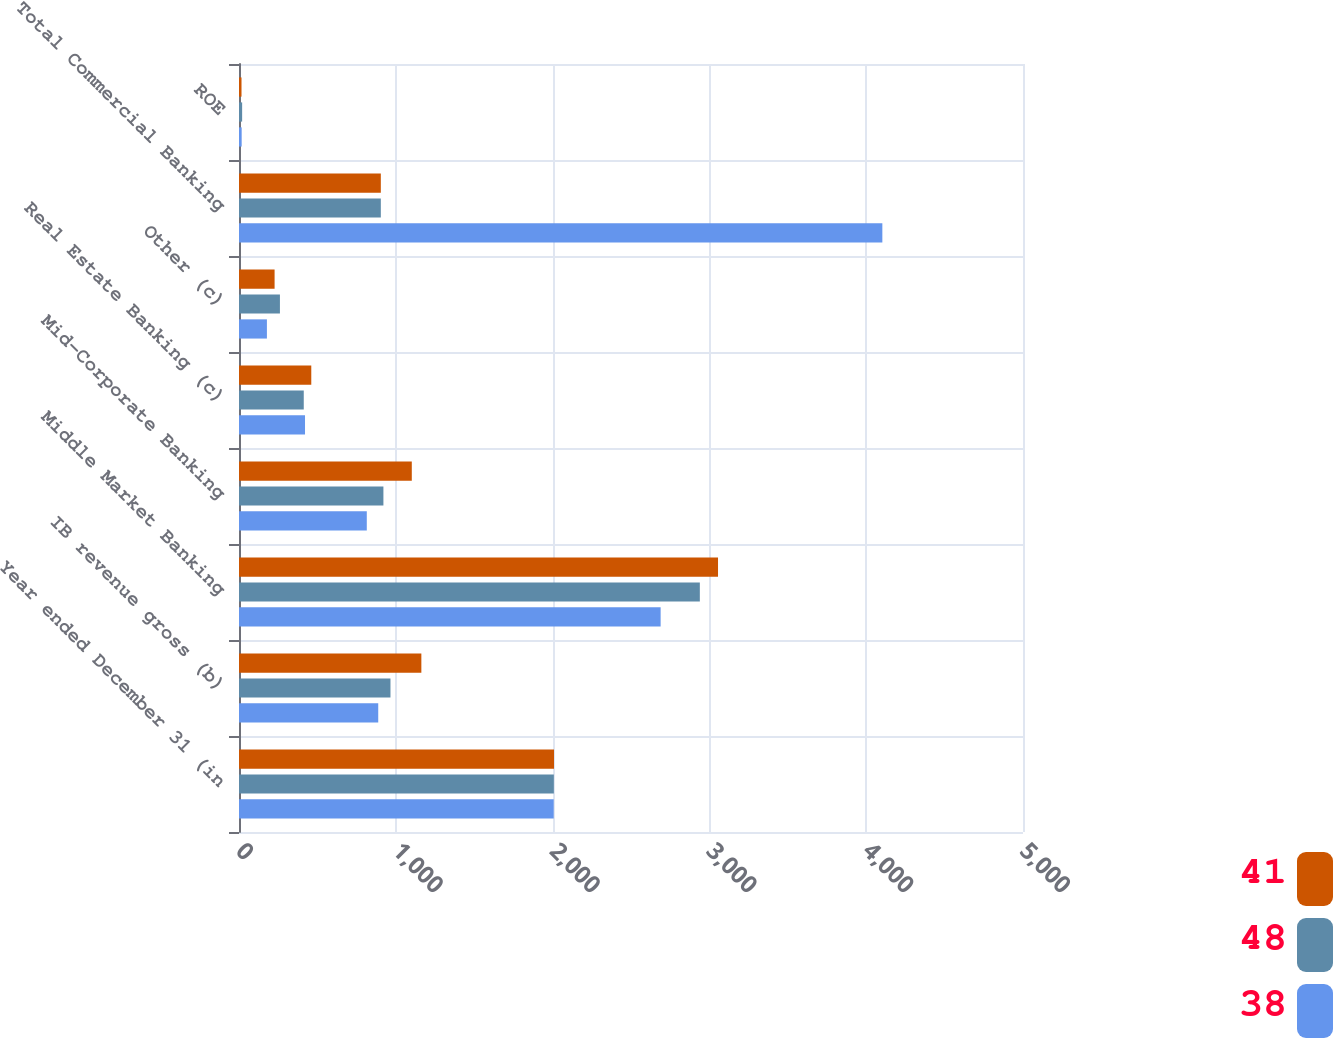Convert chart to OTSL. <chart><loc_0><loc_0><loc_500><loc_500><stacked_bar_chart><ecel><fcel>Year ended December 31 (in<fcel>IB revenue gross (b)<fcel>Middle Market Banking<fcel>Mid-Corporate Banking<fcel>Real Estate Banking (c)<fcel>Other (c)<fcel>Total Commercial Banking<fcel>ROE<nl><fcel>41<fcel>2009<fcel>1163<fcel>3055<fcel>1102<fcel>461<fcel>227<fcel>904.5<fcel>16<nl><fcel>48<fcel>2008<fcel>966<fcel>2939<fcel>921<fcel>413<fcel>261<fcel>904.5<fcel>20<nl><fcel>38<fcel>2007<fcel>888<fcel>2689<fcel>815<fcel>421<fcel>178<fcel>4103<fcel>17<nl></chart> 